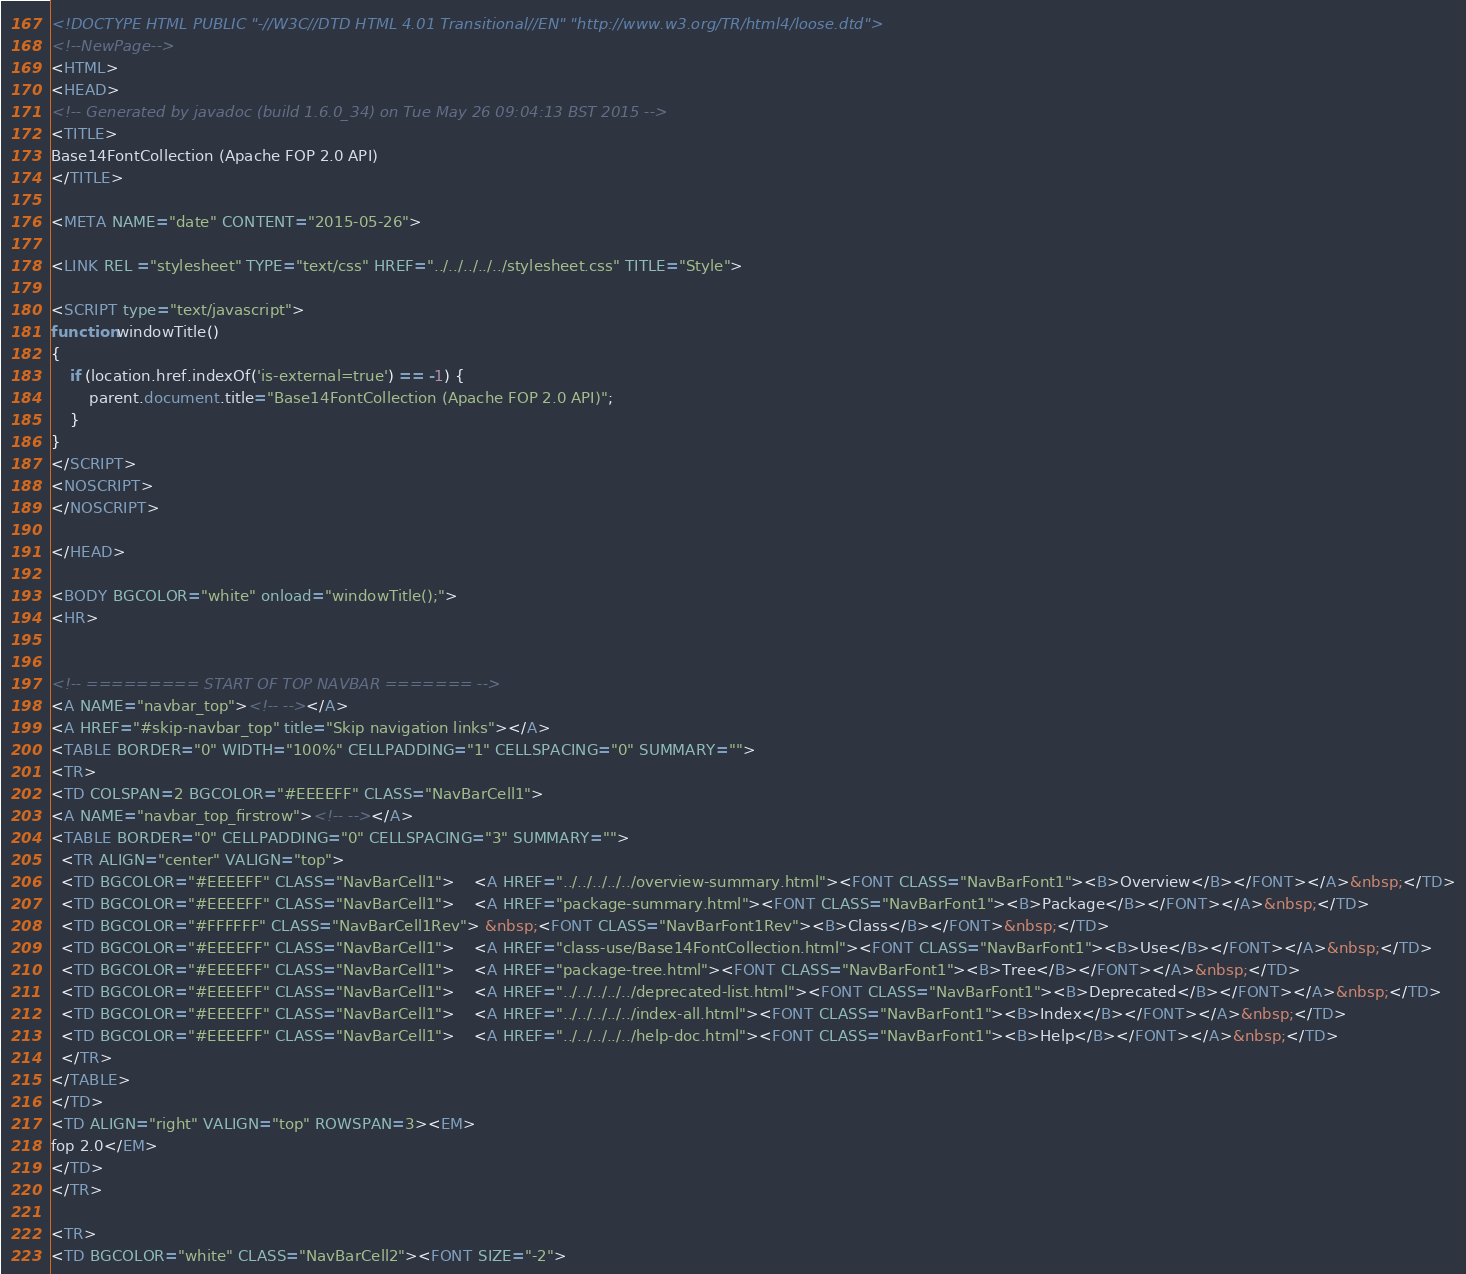<code> <loc_0><loc_0><loc_500><loc_500><_HTML_><!DOCTYPE HTML PUBLIC "-//W3C//DTD HTML 4.01 Transitional//EN" "http://www.w3.org/TR/html4/loose.dtd">
<!--NewPage-->
<HTML>
<HEAD>
<!-- Generated by javadoc (build 1.6.0_34) on Tue May 26 09:04:13 BST 2015 -->
<TITLE>
Base14FontCollection (Apache FOP 2.0 API)
</TITLE>

<META NAME="date" CONTENT="2015-05-26">

<LINK REL ="stylesheet" TYPE="text/css" HREF="../../../../../stylesheet.css" TITLE="Style">

<SCRIPT type="text/javascript">
function windowTitle()
{
    if (location.href.indexOf('is-external=true') == -1) {
        parent.document.title="Base14FontCollection (Apache FOP 2.0 API)";
    }
}
</SCRIPT>
<NOSCRIPT>
</NOSCRIPT>

</HEAD>

<BODY BGCOLOR="white" onload="windowTitle();">
<HR>


<!-- ========= START OF TOP NAVBAR ======= -->
<A NAME="navbar_top"><!-- --></A>
<A HREF="#skip-navbar_top" title="Skip navigation links"></A>
<TABLE BORDER="0" WIDTH="100%" CELLPADDING="1" CELLSPACING="0" SUMMARY="">
<TR>
<TD COLSPAN=2 BGCOLOR="#EEEEFF" CLASS="NavBarCell1">
<A NAME="navbar_top_firstrow"><!-- --></A>
<TABLE BORDER="0" CELLPADDING="0" CELLSPACING="3" SUMMARY="">
  <TR ALIGN="center" VALIGN="top">
  <TD BGCOLOR="#EEEEFF" CLASS="NavBarCell1">    <A HREF="../../../../../overview-summary.html"><FONT CLASS="NavBarFont1"><B>Overview</B></FONT></A>&nbsp;</TD>
  <TD BGCOLOR="#EEEEFF" CLASS="NavBarCell1">    <A HREF="package-summary.html"><FONT CLASS="NavBarFont1"><B>Package</B></FONT></A>&nbsp;</TD>
  <TD BGCOLOR="#FFFFFF" CLASS="NavBarCell1Rev"> &nbsp;<FONT CLASS="NavBarFont1Rev"><B>Class</B></FONT>&nbsp;</TD>
  <TD BGCOLOR="#EEEEFF" CLASS="NavBarCell1">    <A HREF="class-use/Base14FontCollection.html"><FONT CLASS="NavBarFont1"><B>Use</B></FONT></A>&nbsp;</TD>
  <TD BGCOLOR="#EEEEFF" CLASS="NavBarCell1">    <A HREF="package-tree.html"><FONT CLASS="NavBarFont1"><B>Tree</B></FONT></A>&nbsp;</TD>
  <TD BGCOLOR="#EEEEFF" CLASS="NavBarCell1">    <A HREF="../../../../../deprecated-list.html"><FONT CLASS="NavBarFont1"><B>Deprecated</B></FONT></A>&nbsp;</TD>
  <TD BGCOLOR="#EEEEFF" CLASS="NavBarCell1">    <A HREF="../../../../../index-all.html"><FONT CLASS="NavBarFont1"><B>Index</B></FONT></A>&nbsp;</TD>
  <TD BGCOLOR="#EEEEFF" CLASS="NavBarCell1">    <A HREF="../../../../../help-doc.html"><FONT CLASS="NavBarFont1"><B>Help</B></FONT></A>&nbsp;</TD>
  </TR>
</TABLE>
</TD>
<TD ALIGN="right" VALIGN="top" ROWSPAN=3><EM>
fop 2.0</EM>
</TD>
</TR>

<TR>
<TD BGCOLOR="white" CLASS="NavBarCell2"><FONT SIZE="-2"></code> 